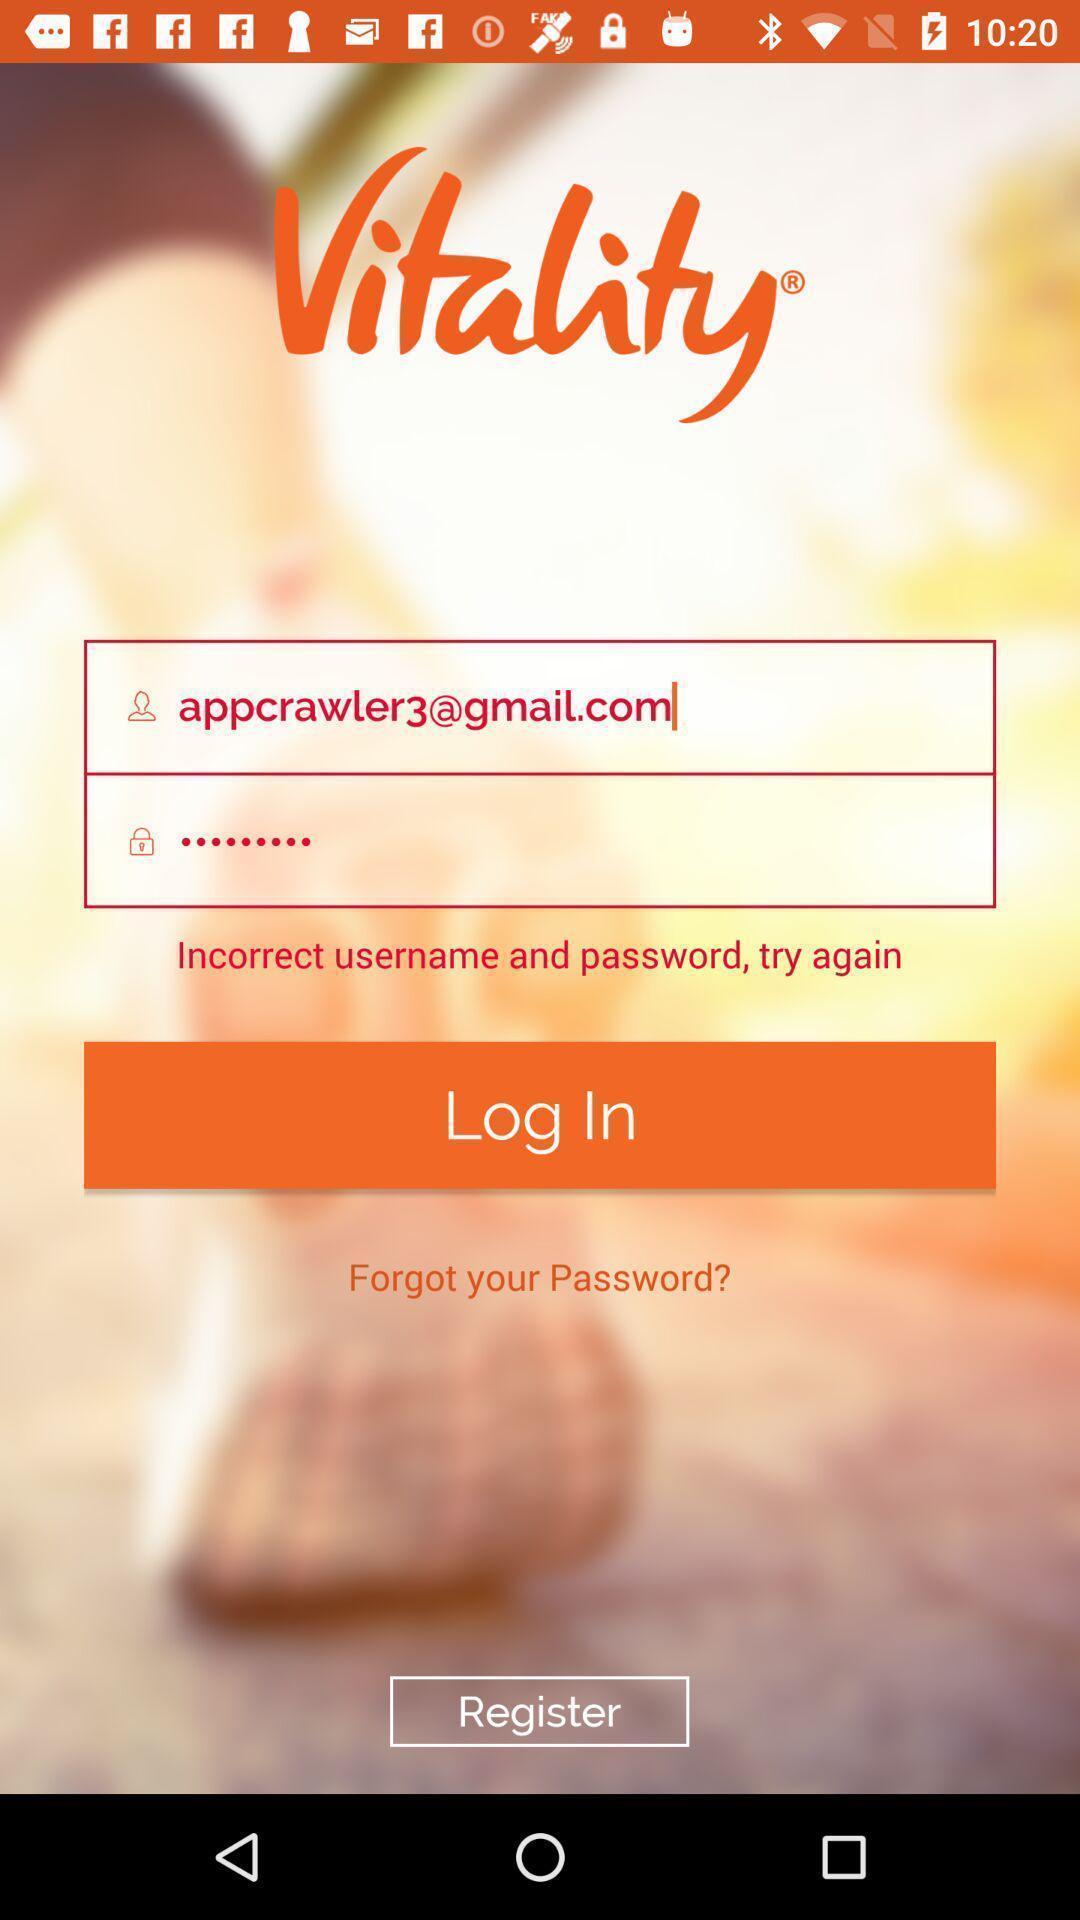Provide a detailed account of this screenshot. Login page of an employees app. 